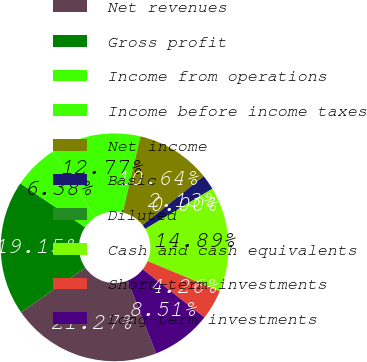<chart> <loc_0><loc_0><loc_500><loc_500><pie_chart><fcel>Net revenues<fcel>Gross profit<fcel>Income from operations<fcel>Income before income taxes<fcel>Net income<fcel>Basic<fcel>Diluted<fcel>Cash and cash equivalents<fcel>Short-term investments<fcel>Long-term investments<nl><fcel>21.27%<fcel>19.15%<fcel>6.38%<fcel>12.77%<fcel>10.64%<fcel>2.13%<fcel>0.0%<fcel>14.89%<fcel>4.26%<fcel>8.51%<nl></chart> 